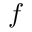Convert formula to latex. <formula><loc_0><loc_0><loc_500><loc_500>f</formula> 